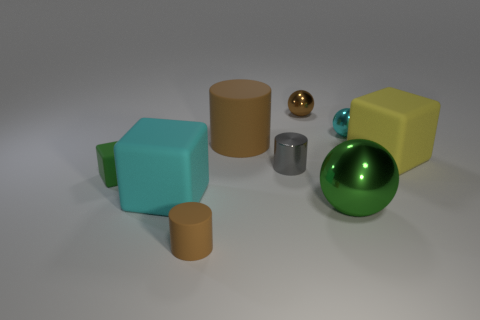Subtract all tiny spheres. How many spheres are left? 1 Subtract all gray spheres. How many brown cylinders are left? 2 Subtract 3 cubes. How many cubes are left? 0 Subtract all spheres. How many objects are left? 6 Add 1 rubber cylinders. How many rubber cylinders are left? 3 Add 7 yellow matte cubes. How many yellow matte cubes exist? 8 Subtract 0 cyan cylinders. How many objects are left? 9 Subtract all yellow balls. Subtract all blue blocks. How many balls are left? 3 Subtract all small brown metallic spheres. Subtract all tiny brown metallic spheres. How many objects are left? 7 